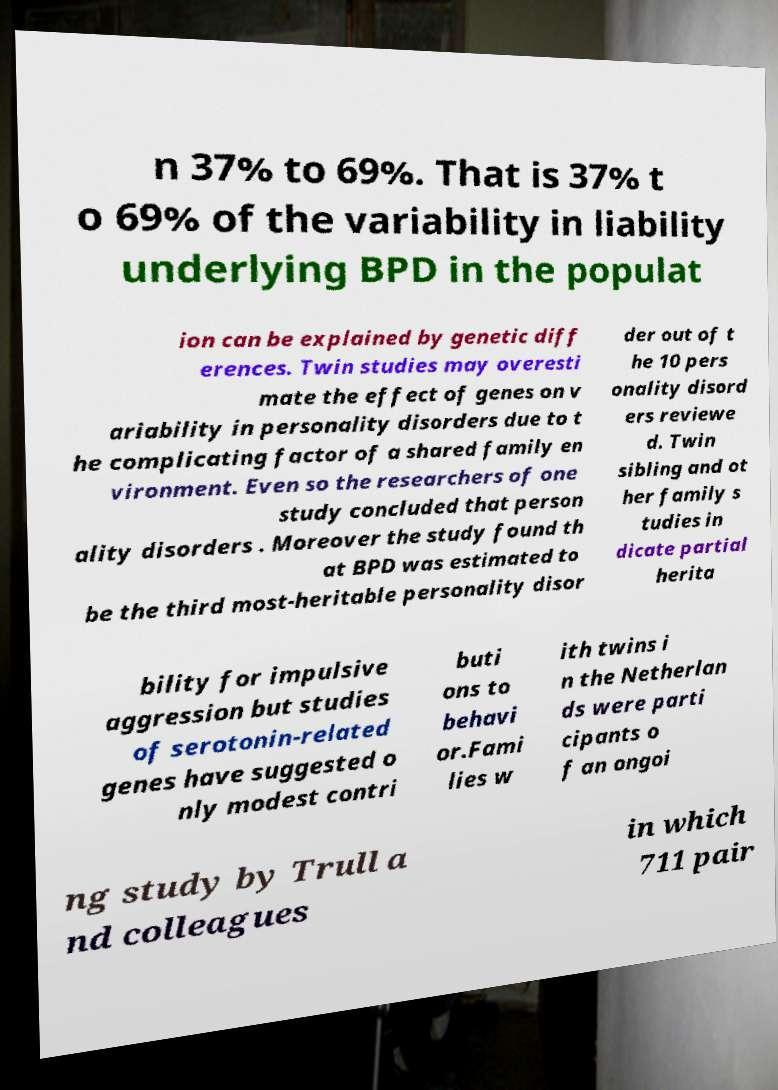Please identify and transcribe the text found in this image. n 37% to 69%. That is 37% t o 69% of the variability in liability underlying BPD in the populat ion can be explained by genetic diff erences. Twin studies may overesti mate the effect of genes on v ariability in personality disorders due to t he complicating factor of a shared family en vironment. Even so the researchers of one study concluded that person ality disorders . Moreover the study found th at BPD was estimated to be the third most-heritable personality disor der out of t he 10 pers onality disord ers reviewe d. Twin sibling and ot her family s tudies in dicate partial herita bility for impulsive aggression but studies of serotonin-related genes have suggested o nly modest contri buti ons to behavi or.Fami lies w ith twins i n the Netherlan ds were parti cipants o f an ongoi ng study by Trull a nd colleagues in which 711 pair 